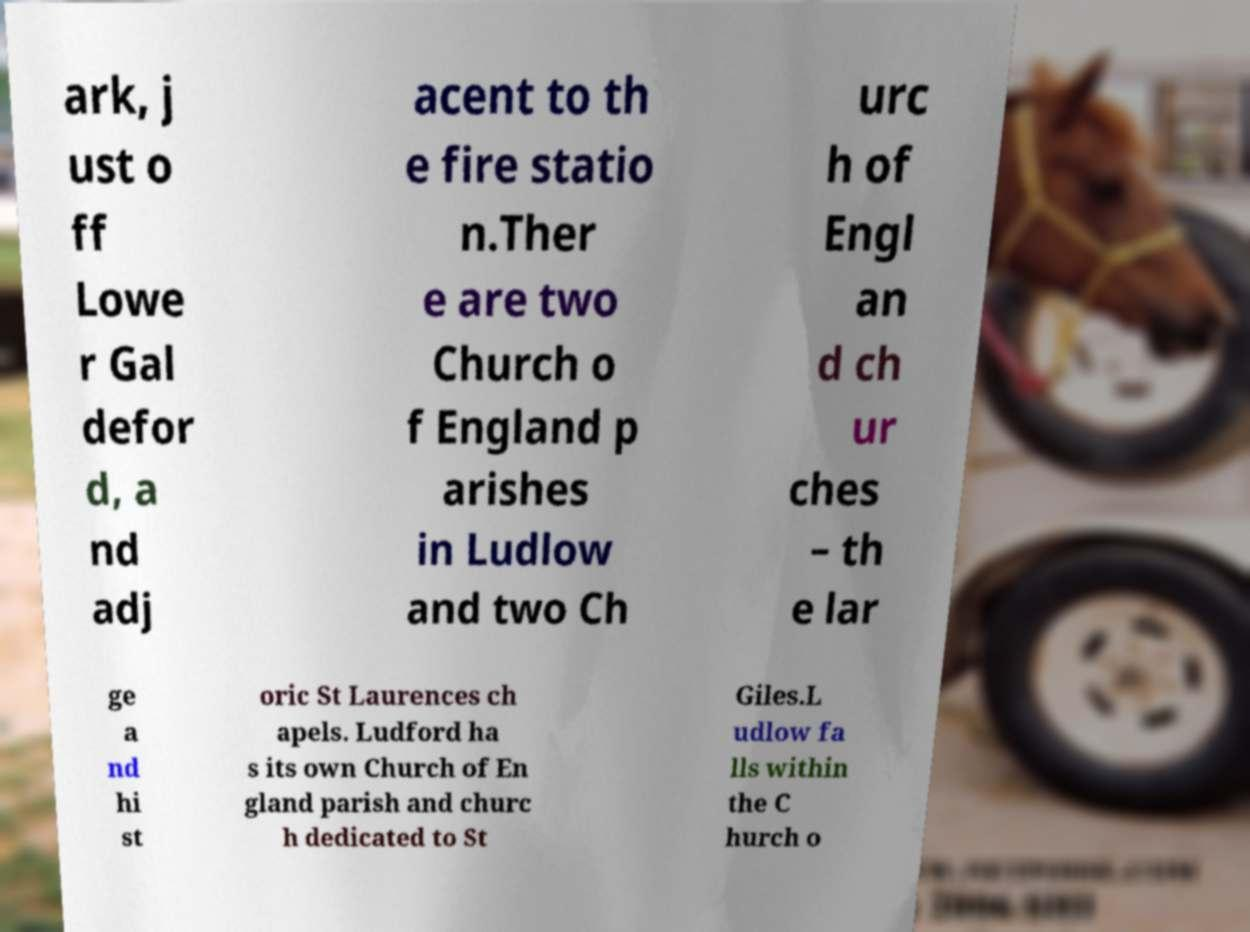Could you assist in decoding the text presented in this image and type it out clearly? ark, j ust o ff Lowe r Gal defor d, a nd adj acent to th e fire statio n.Ther e are two Church o f England p arishes in Ludlow and two Ch urc h of Engl an d ch ur ches – th e lar ge a nd hi st oric St Laurences ch apels. Ludford ha s its own Church of En gland parish and churc h dedicated to St Giles.L udlow fa lls within the C hurch o 